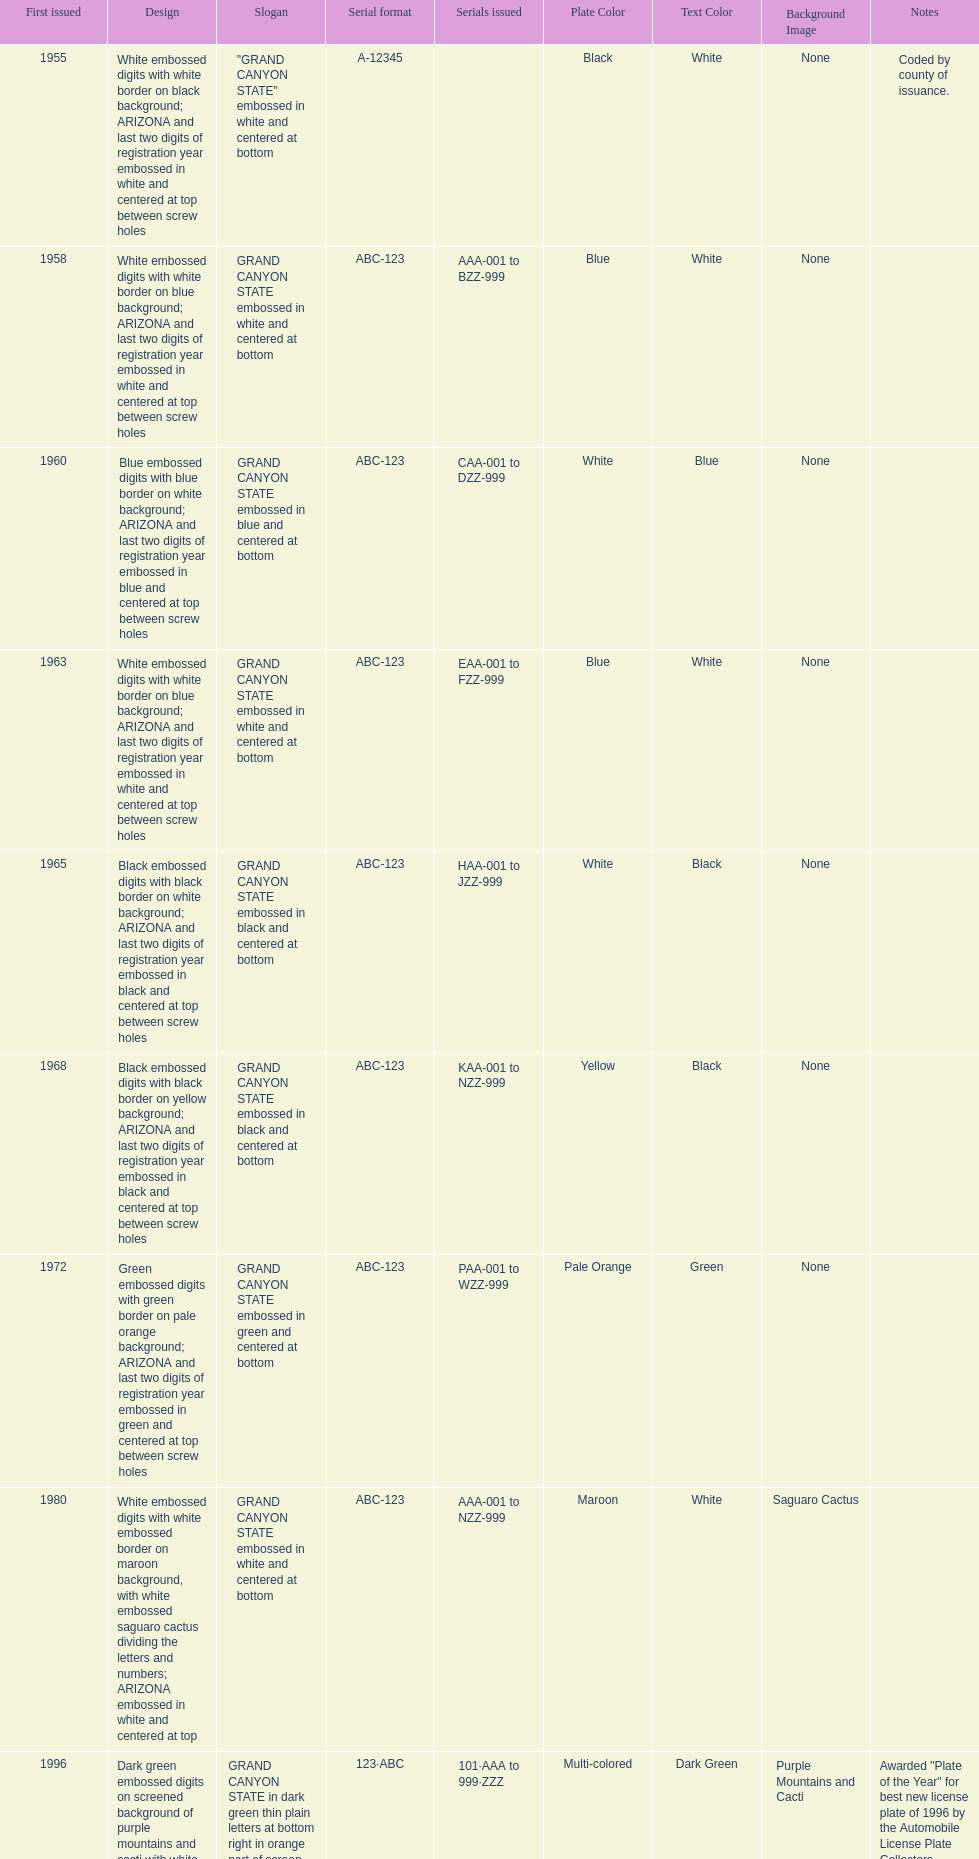What was year was the first arizona license plate made? 1955. 